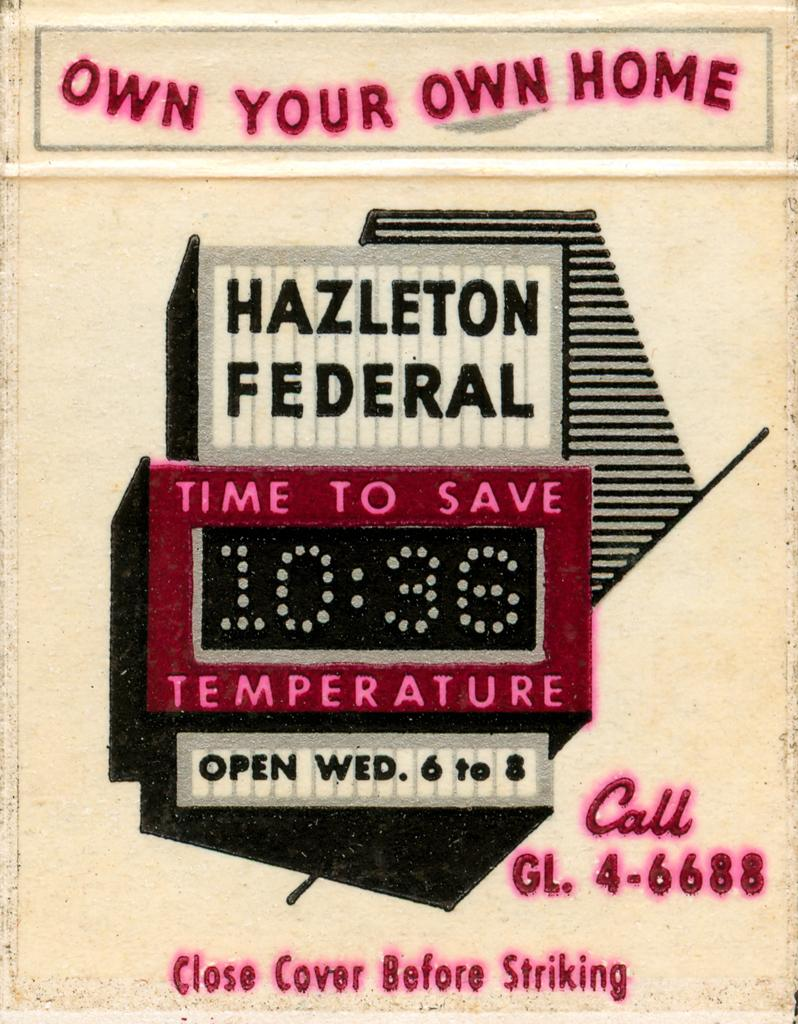<image>
Create a compact narrative representing the image presented. Advertisement that says Own your own home Hazleton Federal Time to save 10:36 Temperature Open Wed. 6 to 8. 